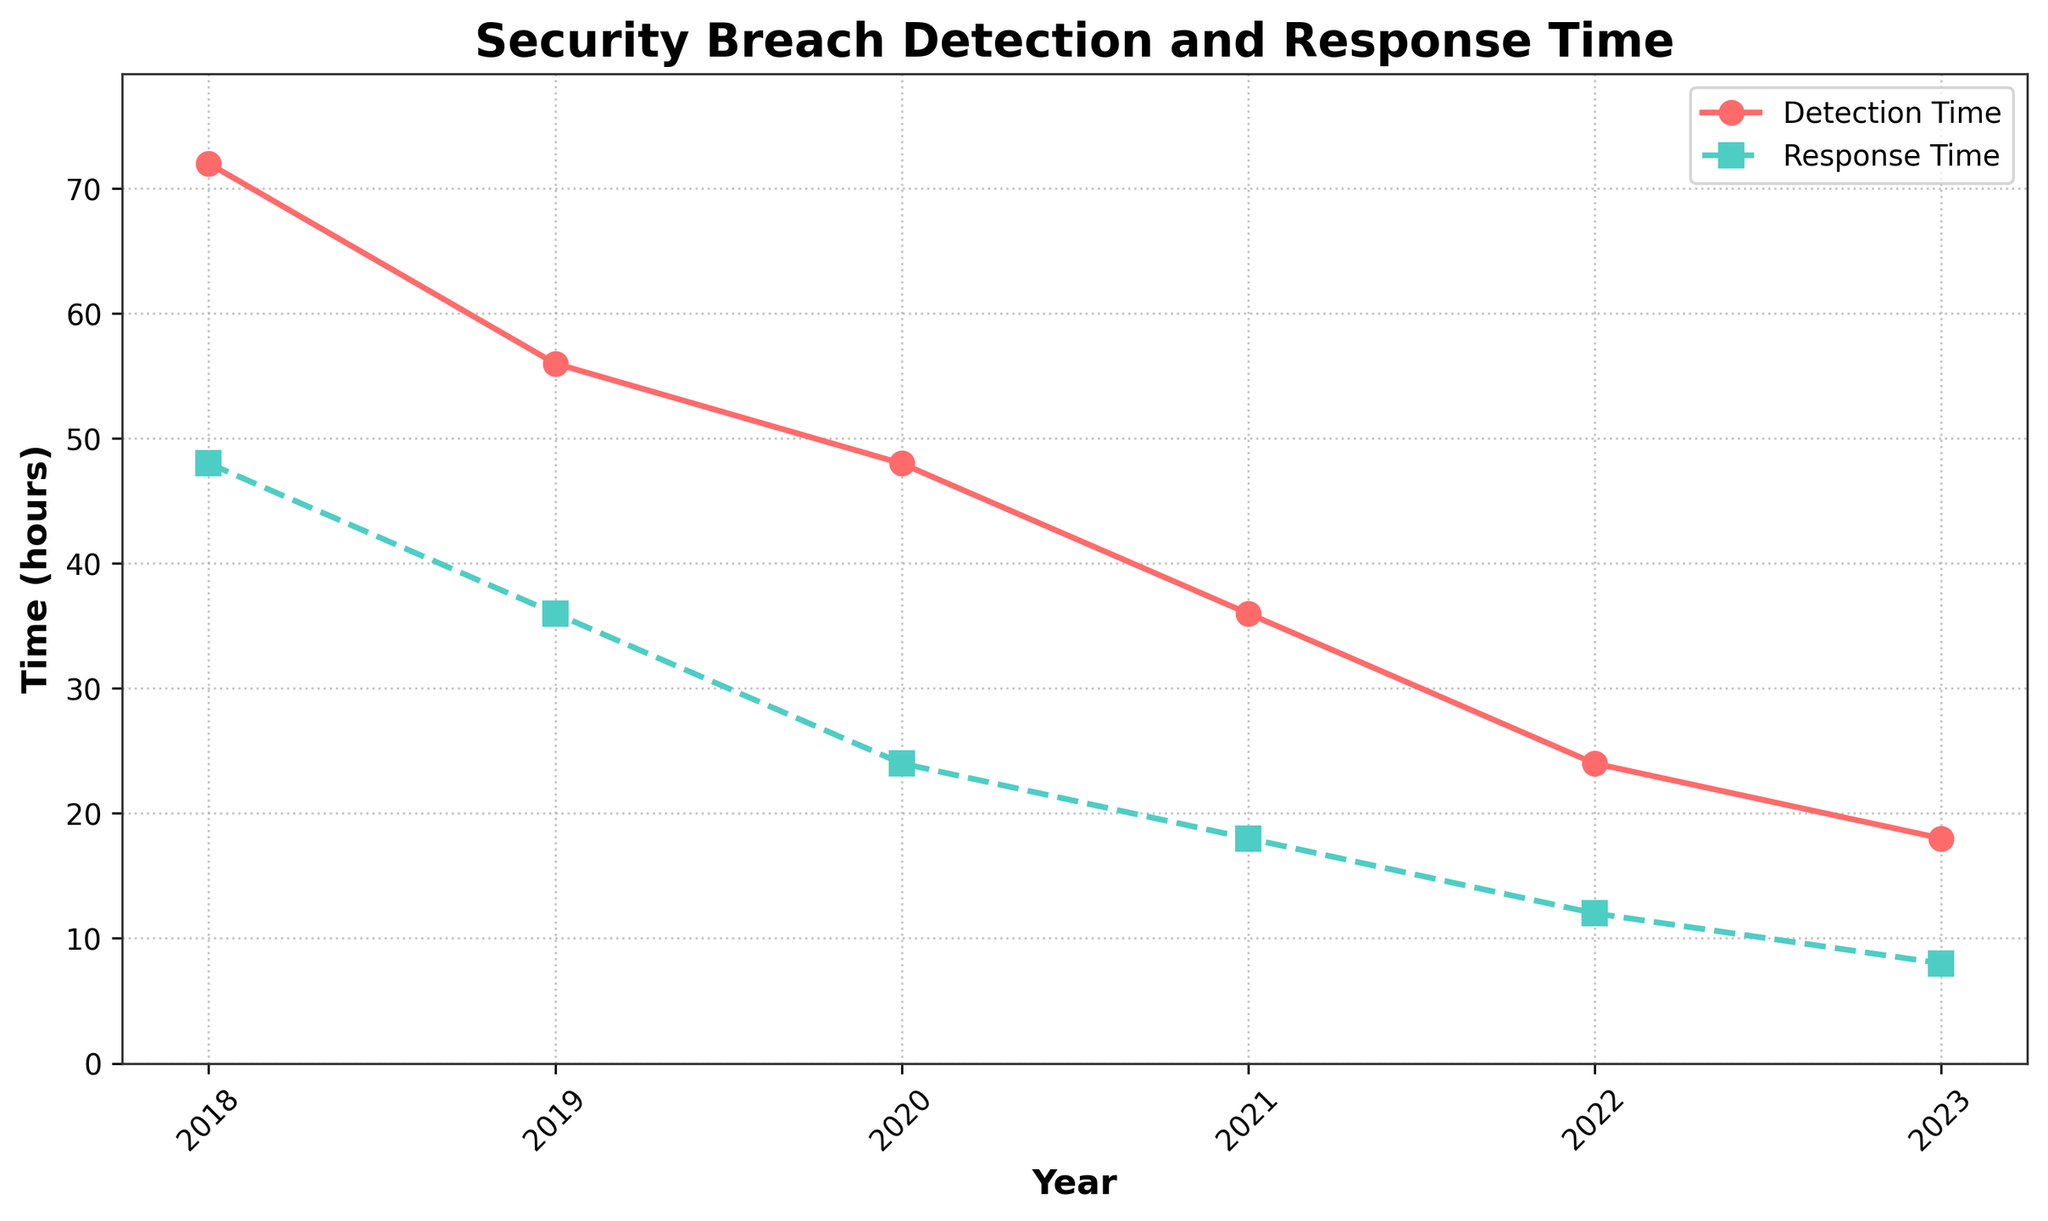What is the title of the line chart? The title is prominently displayed at the top of the chart.
Answer: Security Breach Detection and Response Time What years are displayed on the x-axis? The x-axis labels represent the years.
Answer: 2018, 2019, 2020, 2021, 2022, 2023 Describe the trend in detection time over the five years shown. By plotting the detection times from each year, we see a decreasing trend.
Answer: Detection time is decreasing What was the response time in 2020? The response time in 2020 can be found by locating the corresponding point on the graph.
Answer: 24 hours How much did the detection time decrease from 2019 to 2020? The detection times for 2019 and 2020 are 56 and 48 hours, respectively. Subtracting these yields the decrease.
Answer: 8 hours By how much has the response time improved from 2018 to 2023? The response times for 2018 and 2023 are 48 and 8 hours, respectively. Subtracting these yields the improvement.
Answer: 40 hours Which year saw the greatest decrease in response time? By comparing the changes in response time year-over-year, the largest drop can be identified.
Answer: 2019 In which year did detection time equal twice the response time? Review the chart to find the year where detection time is twice the response time.
Answer: 2020 Are there any years when the detection time is less than twice the response time? Check each year's values to see if detection time is below twice the response time.
Answer: 2021, 2022, 2023 Which curve has a steeper decline, Detection Time or Response Time? Comparing the slopes of the two curves visually, the Response Time curve has steeper downward slopes.
Answer: Response Time 